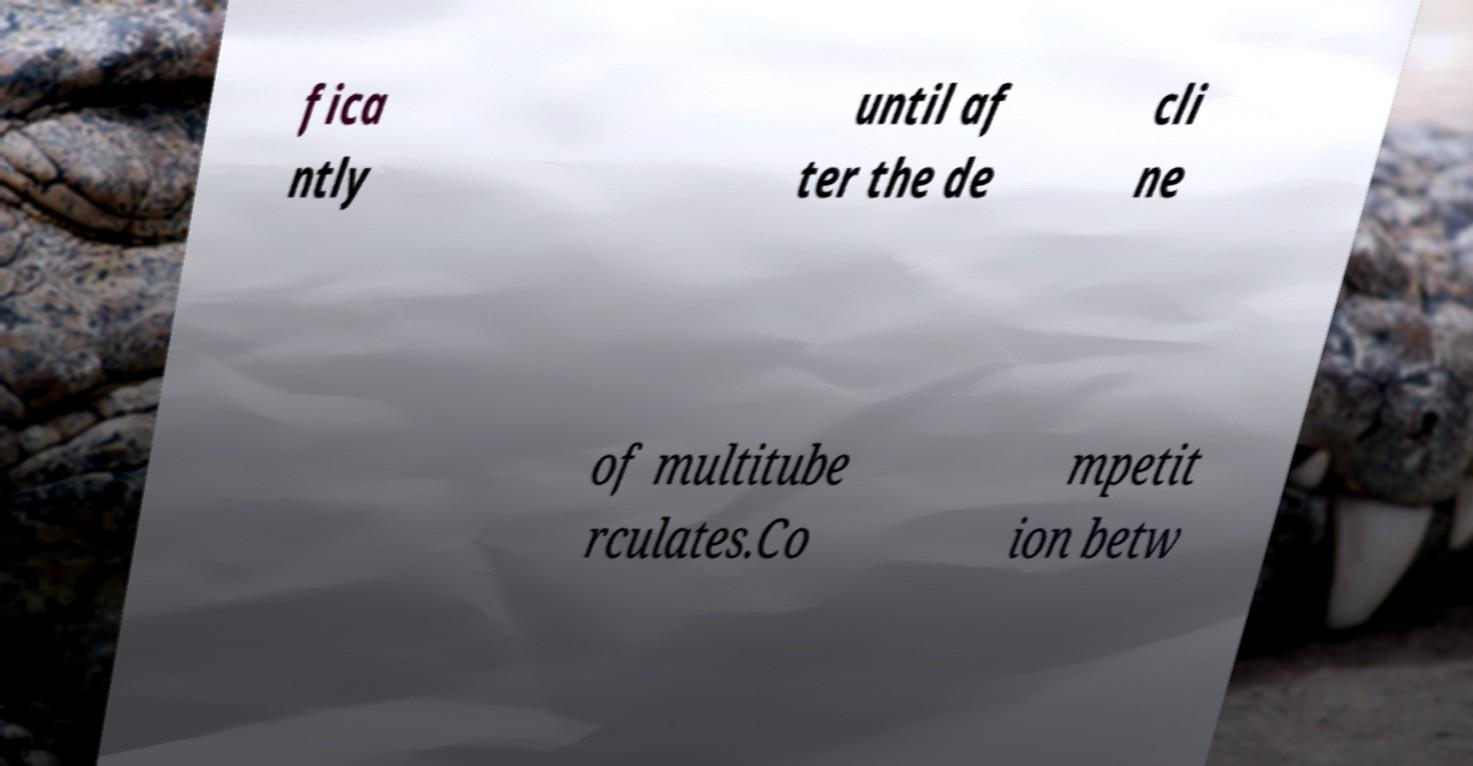There's text embedded in this image that I need extracted. Can you transcribe it verbatim? fica ntly until af ter the de cli ne of multitube rculates.Co mpetit ion betw 